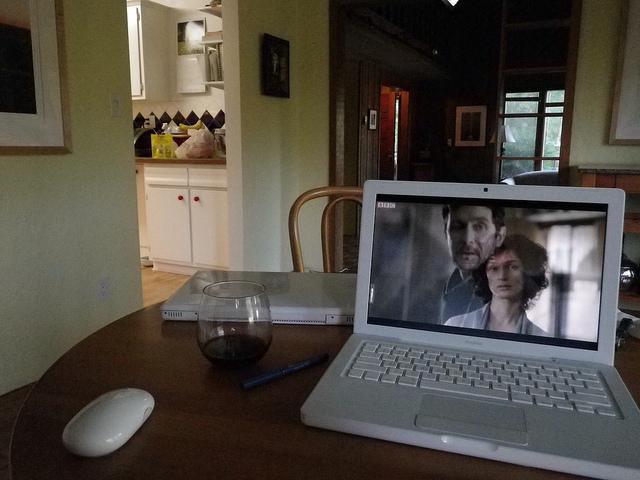How many laptops can be seen?
Give a very brief answer. 2. 